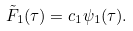<formula> <loc_0><loc_0><loc_500><loc_500>\tilde { F } _ { 1 } ( \tau ) = c _ { 1 } \psi _ { 1 } ( \tau ) .</formula> 